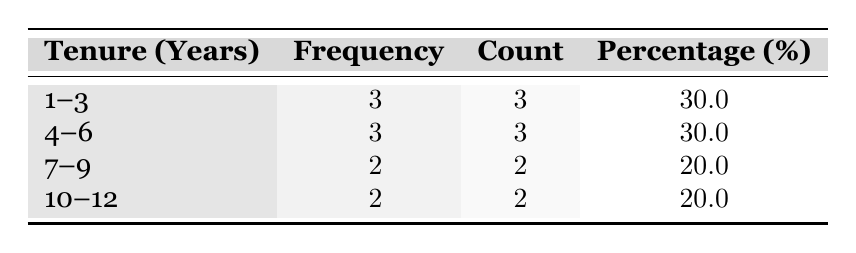What is the total number of employees with a tenure of 1 to 3 years? The table shows that there are 3 employees falling into the 1 to 3 years tenure range. Directly referring to the "Count" column for the row "1--3," we see the frequency is given as 3.
Answer: 3 What percentage of employees have a tenure of 10 to 12 years? The table indicates that the percentage of employees in the 10 to 12 years tenure range is listed as 20.0% under the "Percentage (%)" column for the row "10--12."
Answer: 20.0% How many employees have a tenure between 4 and 9 years? To find this, we need to sum the frequencies of the tenure groups "4--6" and "7--9." The frequency for "4--6" is 3 and for "7--9" is 2. Therefore, the total is 3 + 2 = 5.
Answer: 5 Is it true that the tenure distribution has more employees with less than 6 years of tenure than with 7 years or more? To check this, we can count the frequencies. "1--3" has 3, "4--6" has 3, making a total of 6 for less than 6 years. For 7 and over, "7--9" has 2 and "10--12" has 2, summing to 4. Since 6 > 4, this statement is true.
Answer: Yes What is the average tenure of employees in the corporate office? The tenures for the employees in the table are: 1, 3, 5, 2, 7, 4, 10, 8, 6, and 12. To find the average, we sum all the tenures (1 + 3 + 5 + 2 + 7 + 4 + 10 + 8 + 6 + 12 = 58) and divide by the number of employees (10). Thus, 58/10 = 5.8 years.
Answer: 5.8 